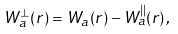<formula> <loc_0><loc_0><loc_500><loc_500>W _ { a } ^ { \perp } ( { r } ) = W _ { a } ( { r } ) - W _ { a } ^ { | | } ( { r } ) \, ,</formula> 